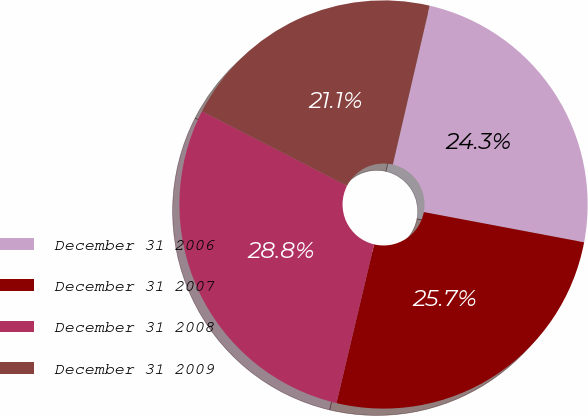Convert chart. <chart><loc_0><loc_0><loc_500><loc_500><pie_chart><fcel>December 31 2006<fcel>December 31 2007<fcel>December 31 2008<fcel>December 31 2009<nl><fcel>24.34%<fcel>25.74%<fcel>28.85%<fcel>21.08%<nl></chart> 